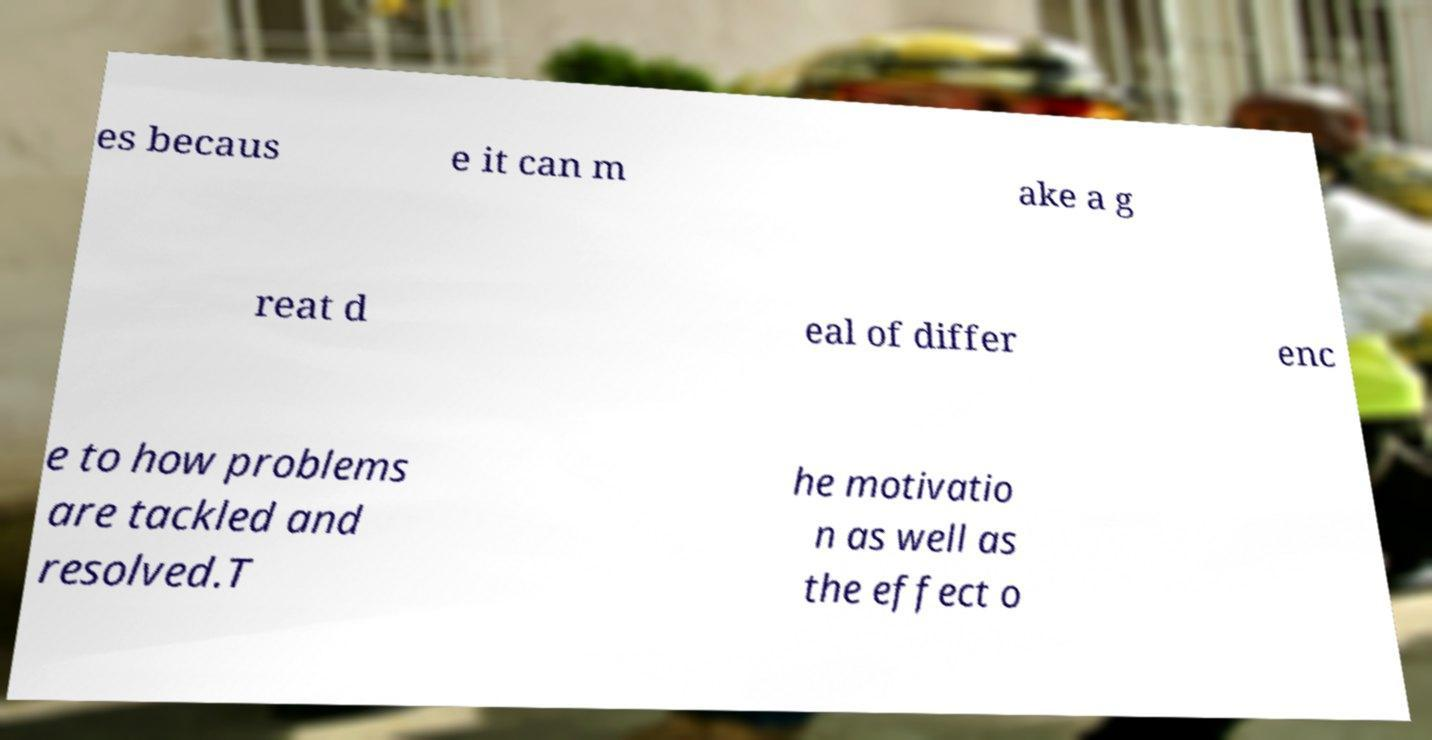I need the written content from this picture converted into text. Can you do that? es becaus e it can m ake a g reat d eal of differ enc e to how problems are tackled and resolved.T he motivatio n as well as the effect o 